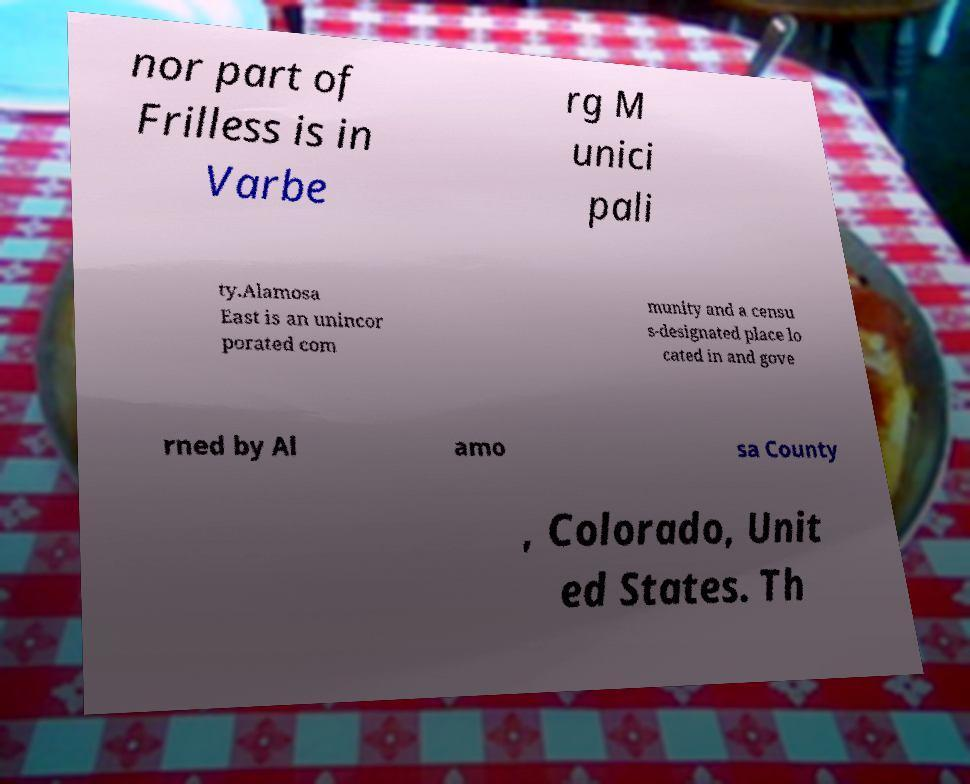Could you assist in decoding the text presented in this image and type it out clearly? nor part of Frilless is in Varbe rg M unici pali ty.Alamosa East is an unincor porated com munity and a censu s-designated place lo cated in and gove rned by Al amo sa County , Colorado, Unit ed States. Th 